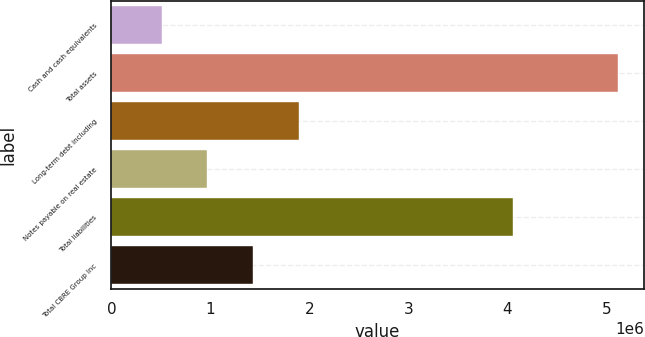<chart> <loc_0><loc_0><loc_500><loc_500><bar_chart><fcel>Cash and cash equivalents<fcel>Total assets<fcel>Long-term debt including<fcel>Notes payable on real estate<fcel>Total liabilities<fcel>Total CBRE Group Inc<nl><fcel>506574<fcel>5.12157e+06<fcel>1.89107e+06<fcel>968073<fcel>4.05577e+06<fcel>1.42957e+06<nl></chart> 